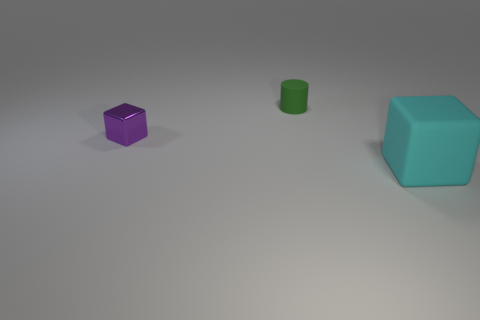Add 1 small rubber blocks. How many objects exist? 4 Subtract all cylinders. How many objects are left? 2 Subtract all cyan blocks. Subtract all tiny brown rubber balls. How many objects are left? 2 Add 2 large cyan things. How many large cyan things are left? 3 Add 3 purple metallic things. How many purple metallic things exist? 4 Subtract 0 red cubes. How many objects are left? 3 